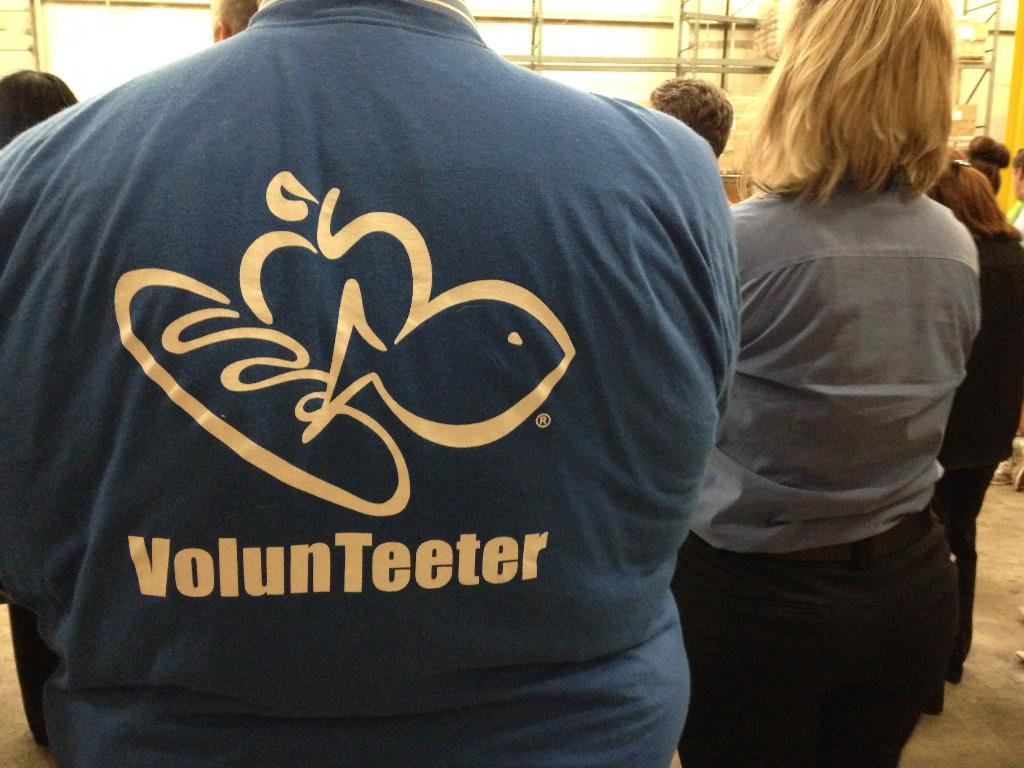Provide a one-sentence caption for the provided image. Several people standing around each other, with the person in the foreground wearing a blue shirt saying "volunteer" on it. 